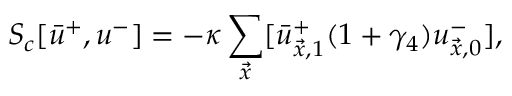Convert formula to latex. <formula><loc_0><loc_0><loc_500><loc_500>S _ { c } [ \bar { u } ^ { + } , u ^ { - } ] = - \kappa \sum _ { \vec { x } } [ \bar { u } _ { \vec { x } , 1 } ^ { + } ( 1 + \gamma _ { 4 } ) u _ { \vec { x } , 0 } ^ { - } ] ,</formula> 